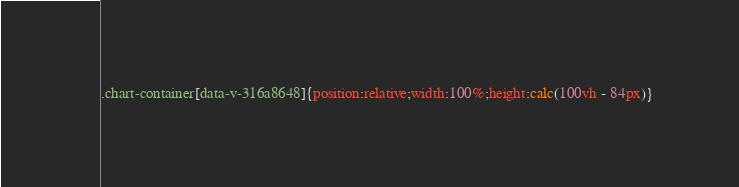<code> <loc_0><loc_0><loc_500><loc_500><_CSS_>.chart-container[data-v-316a8648]{position:relative;width:100%;height:calc(100vh - 84px)}</code> 